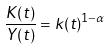Convert formula to latex. <formula><loc_0><loc_0><loc_500><loc_500>\frac { K ( t ) } { Y ( t ) } = k ( t ) ^ { 1 - \alpha }</formula> 